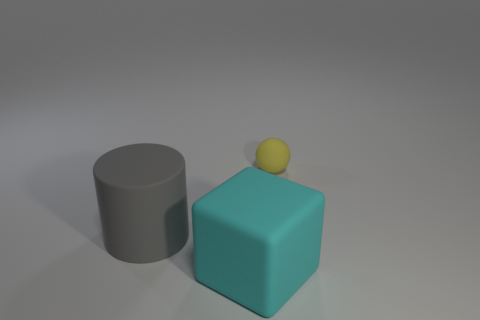How many objects are matte things behind the big gray rubber thing or large brown matte balls?
Your answer should be compact. 1. How many other objects are there of the same shape as the yellow object?
Offer a terse response. 0. How many objects are matte things that are on the left side of the sphere or objects in front of the small yellow matte sphere?
Offer a terse response. 2. Is the number of tiny yellow matte objects in front of the cyan rubber thing less than the number of blocks that are in front of the tiny ball?
Offer a very short reply. Yes. How many large matte things are there?
Your answer should be compact. 2. Are there fewer large gray matte objects behind the large gray rubber cylinder than big cyan metal cylinders?
Your response must be concise. No. There is a sphere that is the same material as the big gray cylinder; what is its size?
Offer a terse response. Small. What material is the object on the left side of the object in front of the thing to the left of the big cyan rubber thing made of?
Ensure brevity in your answer.  Rubber. Are there fewer cyan blocks than small green metallic cylinders?
Provide a short and direct response. No. What number of things are in front of the big object that is left of the large cube?
Offer a very short reply. 1. 